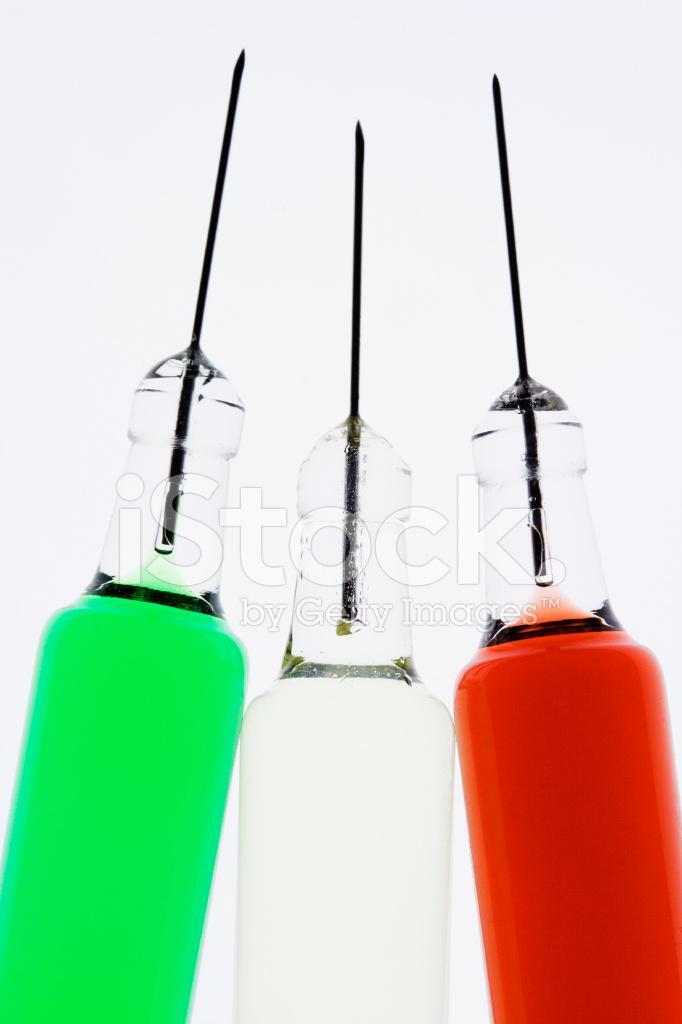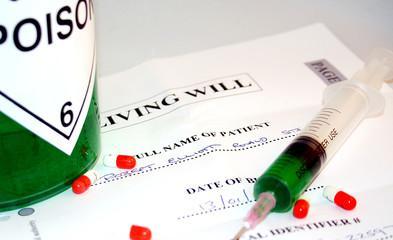The first image is the image on the left, the second image is the image on the right. Examine the images to the left and right. Is the description "Atleast one of the images has 4 needles" accurate? Answer yes or no. No. The first image is the image on the left, the second image is the image on the right. Evaluate the accuracy of this statement regarding the images: "One of the images contains four syringes that appear to be red in color or fill.". Is it true? Answer yes or no. No. 